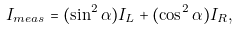Convert formula to latex. <formula><loc_0><loc_0><loc_500><loc_500>I _ { m e a s } = ( \sin ^ { 2 } \alpha ) I _ { L } + ( \cos ^ { 2 } \alpha ) I _ { R } ,</formula> 